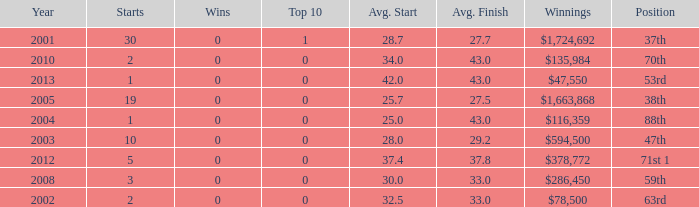Would you mind parsing the complete table? {'header': ['Year', 'Starts', 'Wins', 'Top 10', 'Avg. Start', 'Avg. Finish', 'Winnings', 'Position'], 'rows': [['2001', '30', '0', '1', '28.7', '27.7', '$1,724,692', '37th'], ['2010', '2', '0', '0', '34.0', '43.0', '$135,984', '70th'], ['2013', '1', '0', '0', '42.0', '43.0', '$47,550', '53rd'], ['2005', '19', '0', '0', '25.7', '27.5', '$1,663,868', '38th'], ['2004', '1', '0', '0', '25.0', '43.0', '$116,359', '88th'], ['2003', '10', '0', '0', '28.0', '29.2', '$594,500', '47th'], ['2012', '5', '0', '0', '37.4', '37.8', '$378,772', '71st 1'], ['2008', '3', '0', '0', '30.0', '33.0', '$286,450', '59th'], ['2002', '2', '0', '0', '32.5', '33.0', '$78,500', '63rd']]} How many starts for an average finish greater than 43? None. 